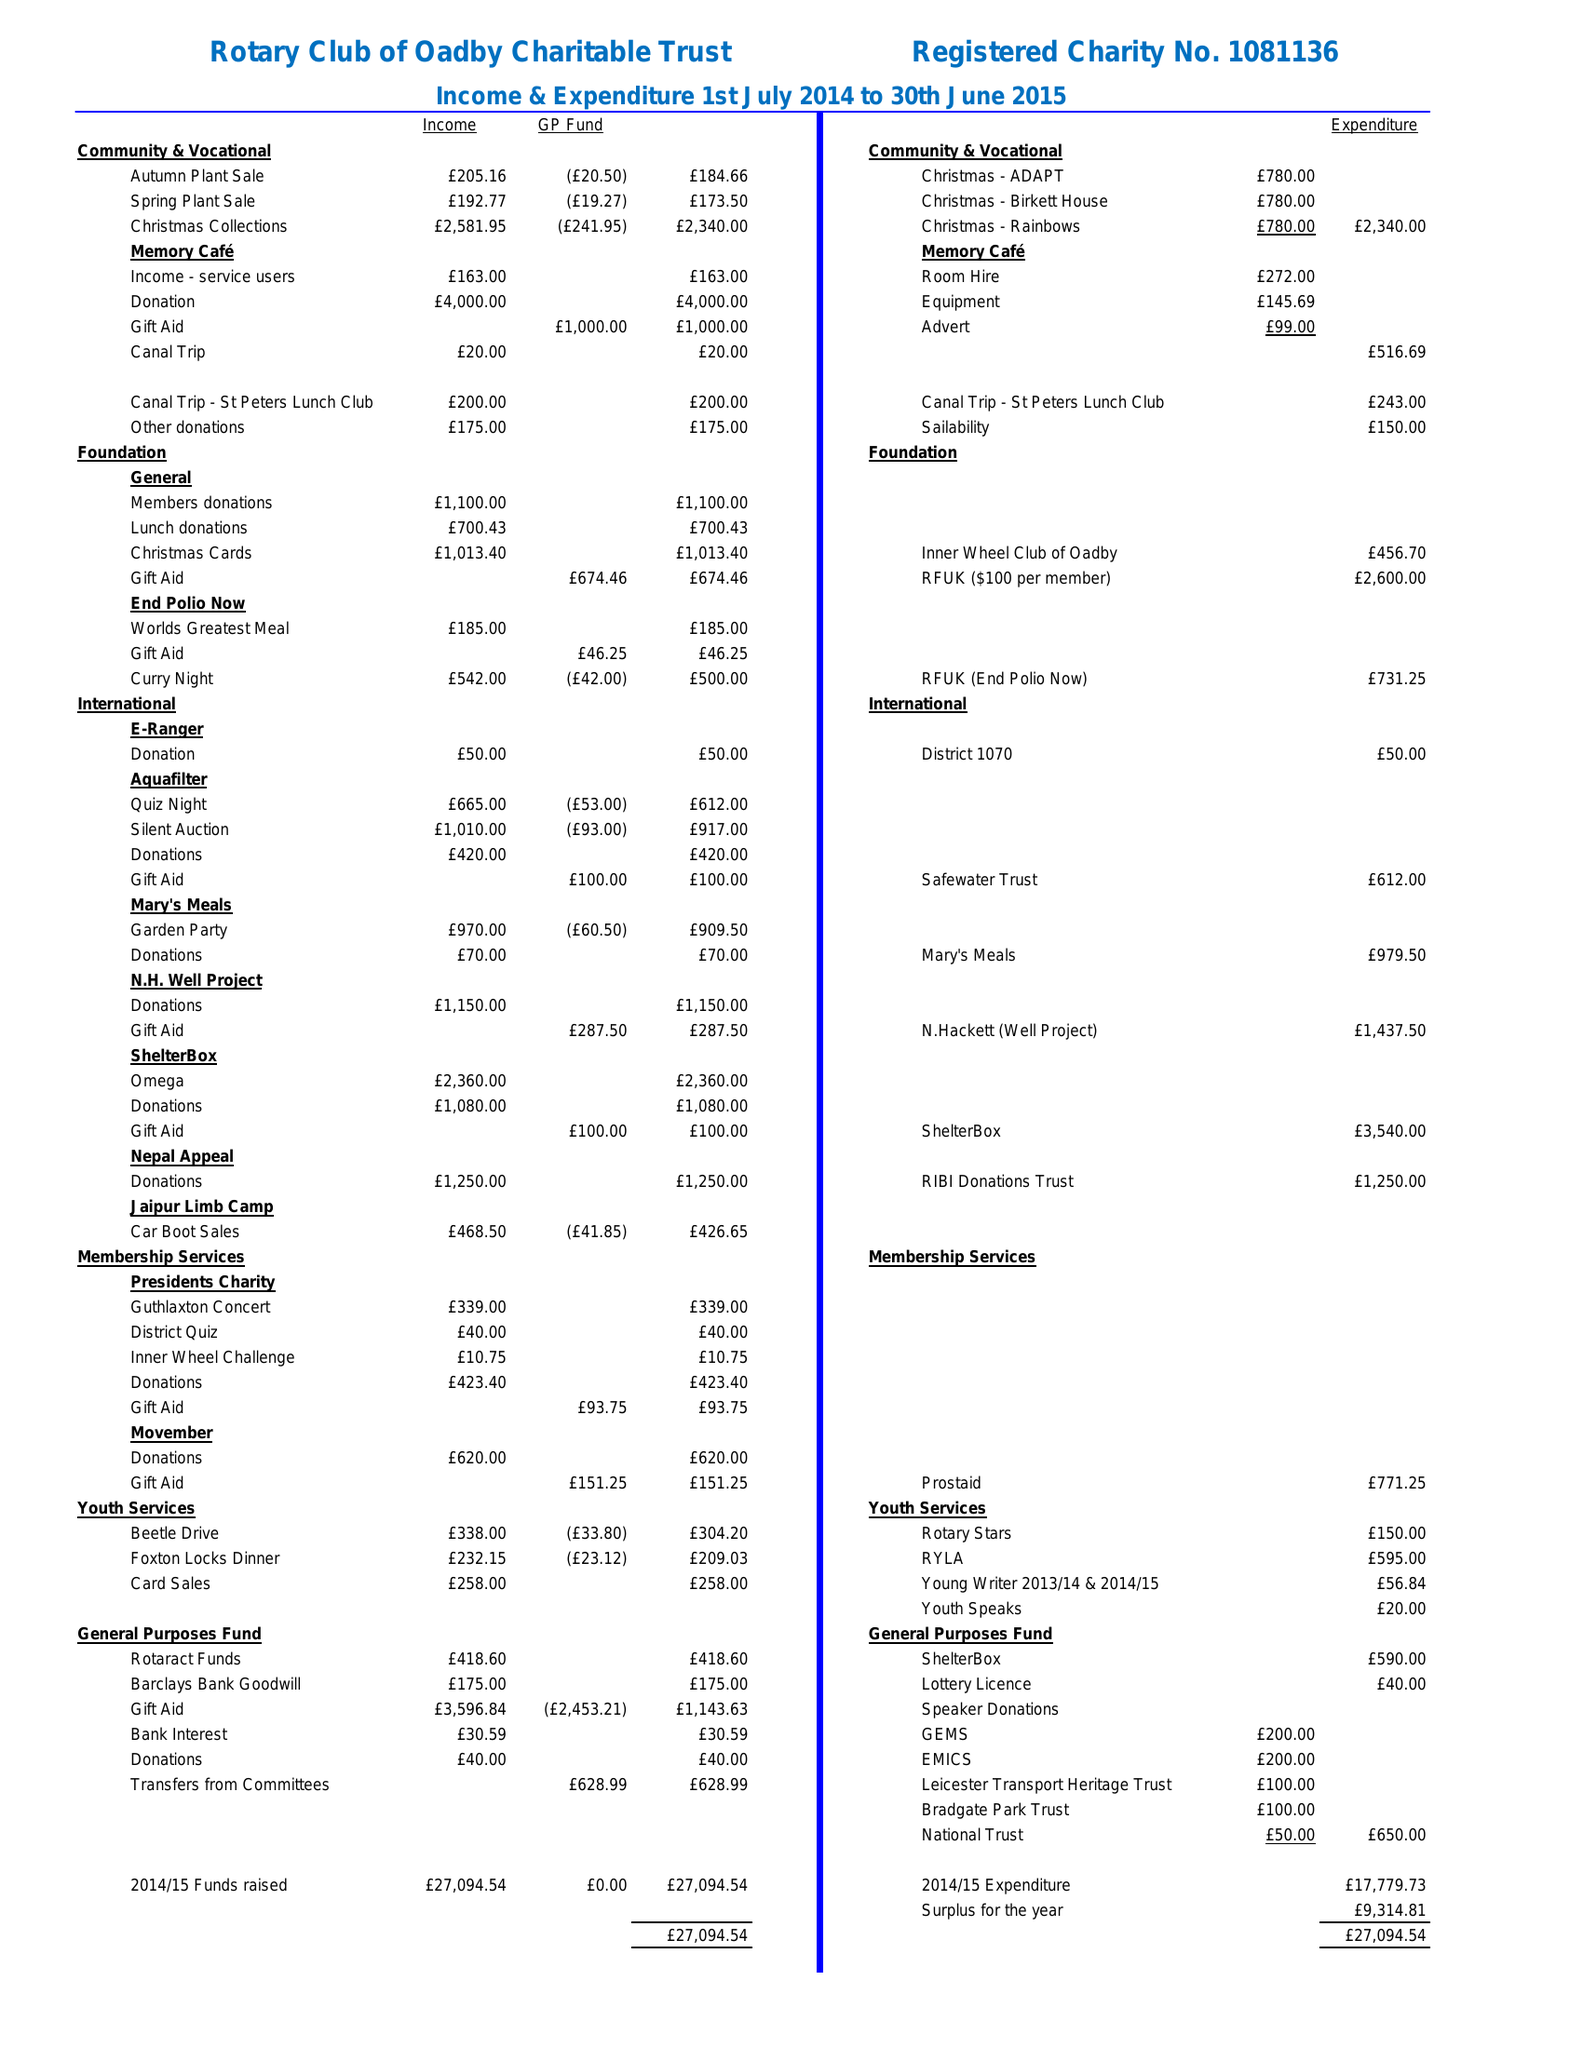What is the value for the charity_name?
Answer the question using a single word or phrase. Rotary Club Of Oadby Charitable Trust 